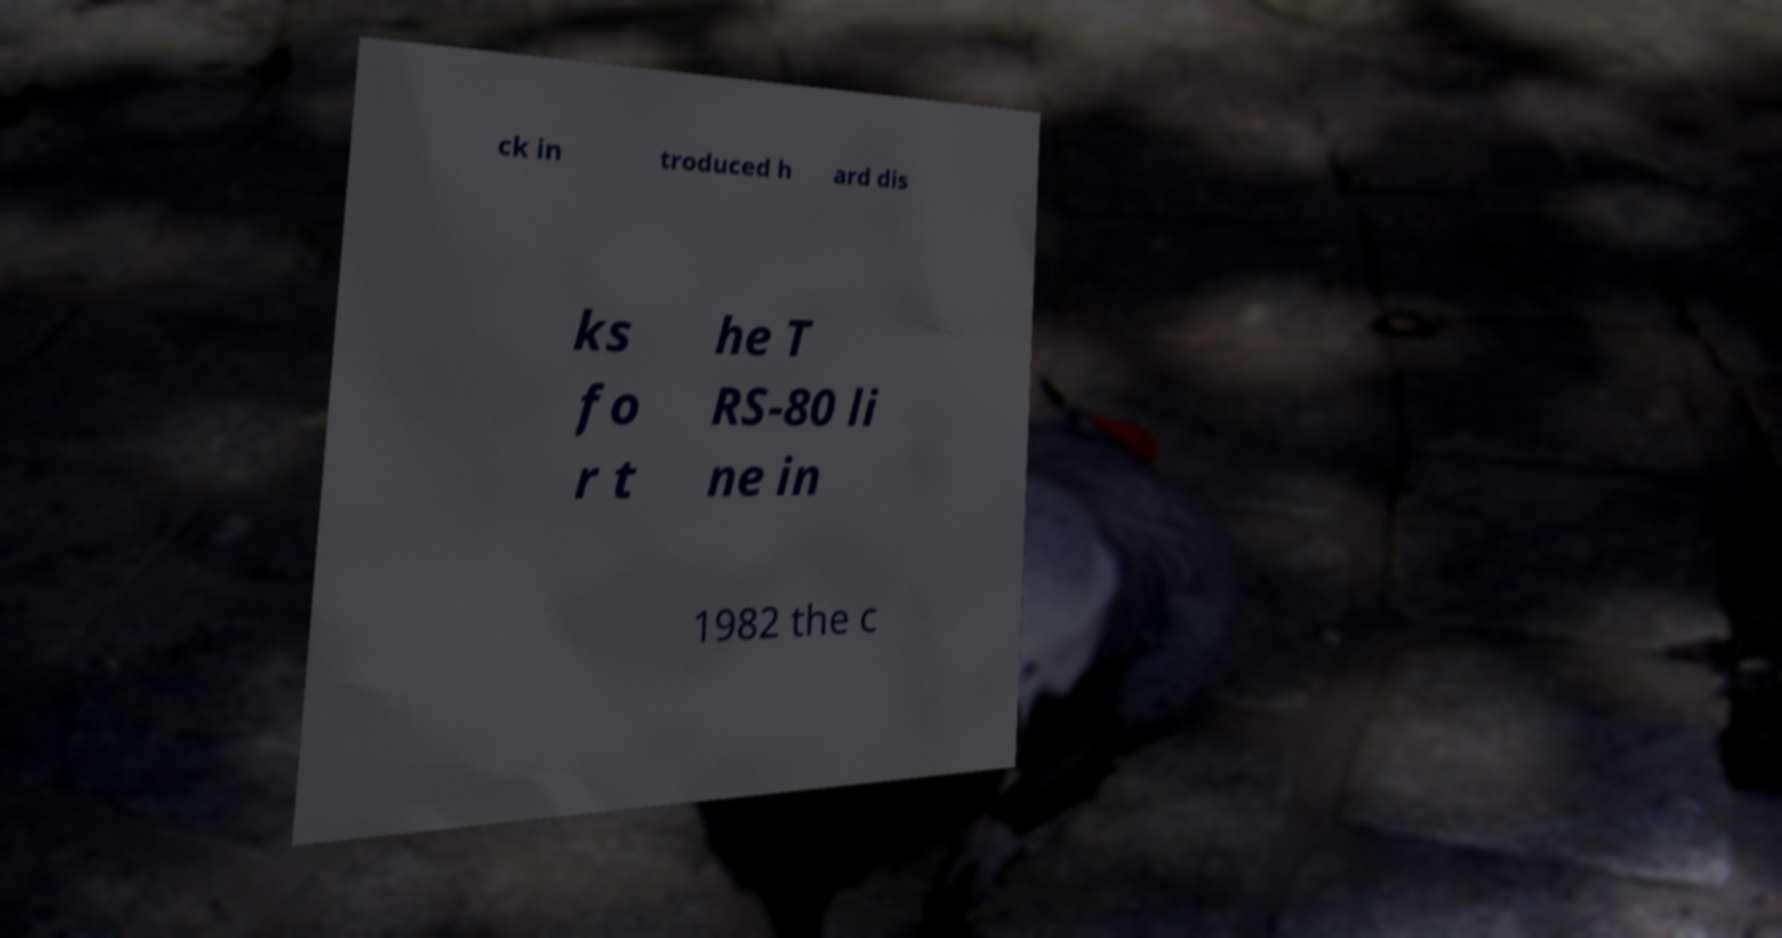For documentation purposes, I need the text within this image transcribed. Could you provide that? ck in troduced h ard dis ks fo r t he T RS-80 li ne in 1982 the c 